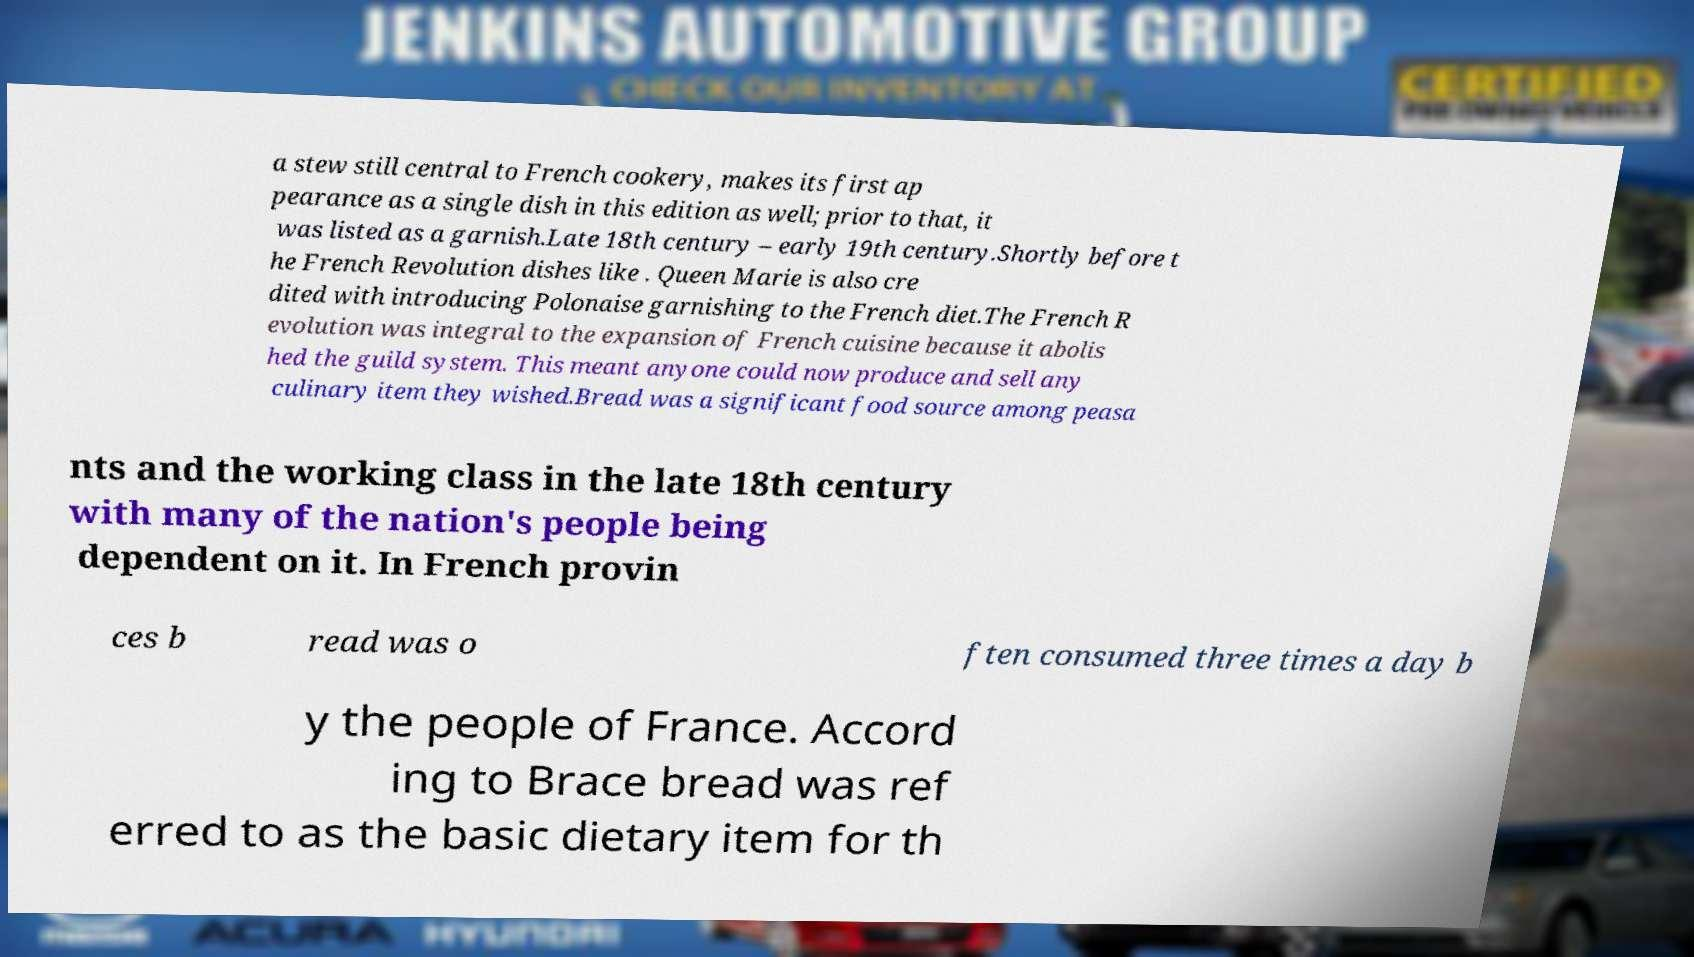What messages or text are displayed in this image? I need them in a readable, typed format. a stew still central to French cookery, makes its first ap pearance as a single dish in this edition as well; prior to that, it was listed as a garnish.Late 18th century – early 19th century.Shortly before t he French Revolution dishes like . Queen Marie is also cre dited with introducing Polonaise garnishing to the French diet.The French R evolution was integral to the expansion of French cuisine because it abolis hed the guild system. This meant anyone could now produce and sell any culinary item they wished.Bread was a significant food source among peasa nts and the working class in the late 18th century with many of the nation's people being dependent on it. In French provin ces b read was o ften consumed three times a day b y the people of France. Accord ing to Brace bread was ref erred to as the basic dietary item for th 